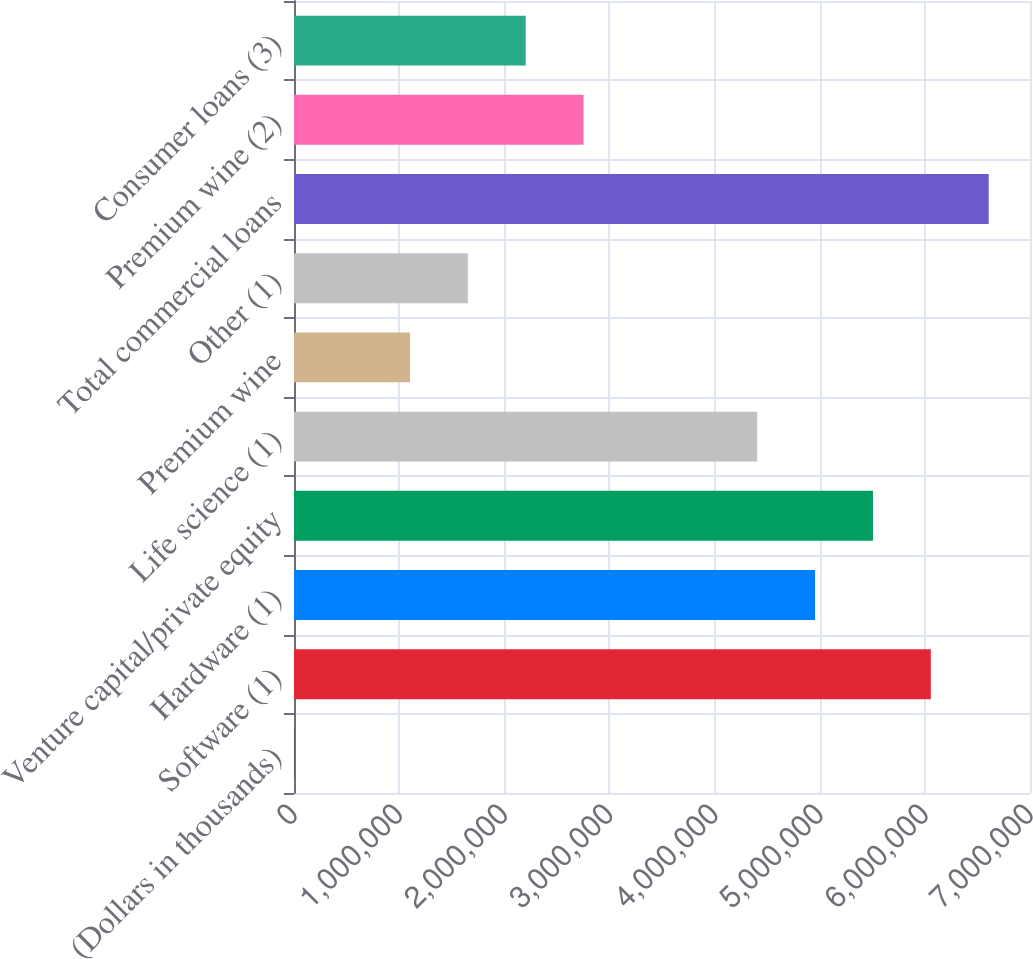Convert chart to OTSL. <chart><loc_0><loc_0><loc_500><loc_500><bar_chart><fcel>(Dollars in thousands)<fcel>Software (1)<fcel>Hardware (1)<fcel>Venture capital/private equity<fcel>Life science (1)<fcel>Premium wine<fcel>Other (1)<fcel>Total commercial loans<fcel>Premium wine (2)<fcel>Consumer loans (3)<nl><fcel>2008<fcel>6.05668e+06<fcel>4.95583e+06<fcel>5.50625e+06<fcel>4.4054e+06<fcel>1.10286e+06<fcel>1.65328e+06<fcel>6.6071e+06<fcel>2.75413e+06<fcel>2.20371e+06<nl></chart> 